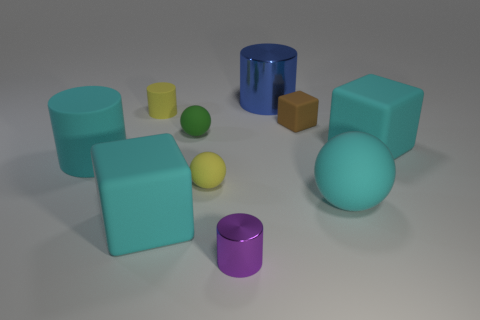Can you tell me what colors the two cubes in the image have? Certainly, the larger cube on the right has a soft teal color, while the smaller cube to its left boasts a rich brown hue.  Are there any shapes with a reflective surface? Yes, the cylindrical shape on the right has a highly reflective blue surface, almost mirror-like in its finish. 